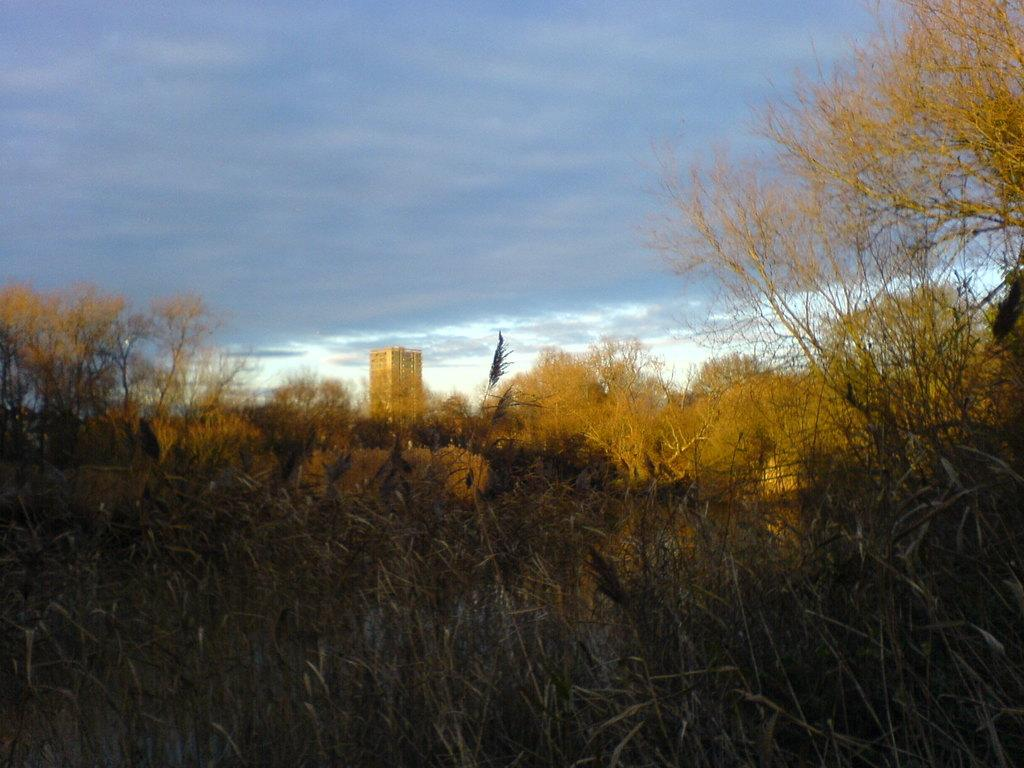What type of surface is visible in the image? There is grass on the surface in the image. What can be seen in the background of the image? There are trees and a building in the background of the image. What is visible in the sky at the top of the image? There are clouds in the sky at the top of the image. Where is the queen sitting in the image? There is no queen present in the image. 